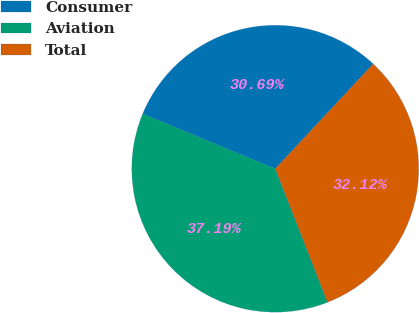<chart> <loc_0><loc_0><loc_500><loc_500><pie_chart><fcel>Consumer<fcel>Aviation<fcel>Total<nl><fcel>30.69%<fcel>37.19%<fcel>32.12%<nl></chart> 